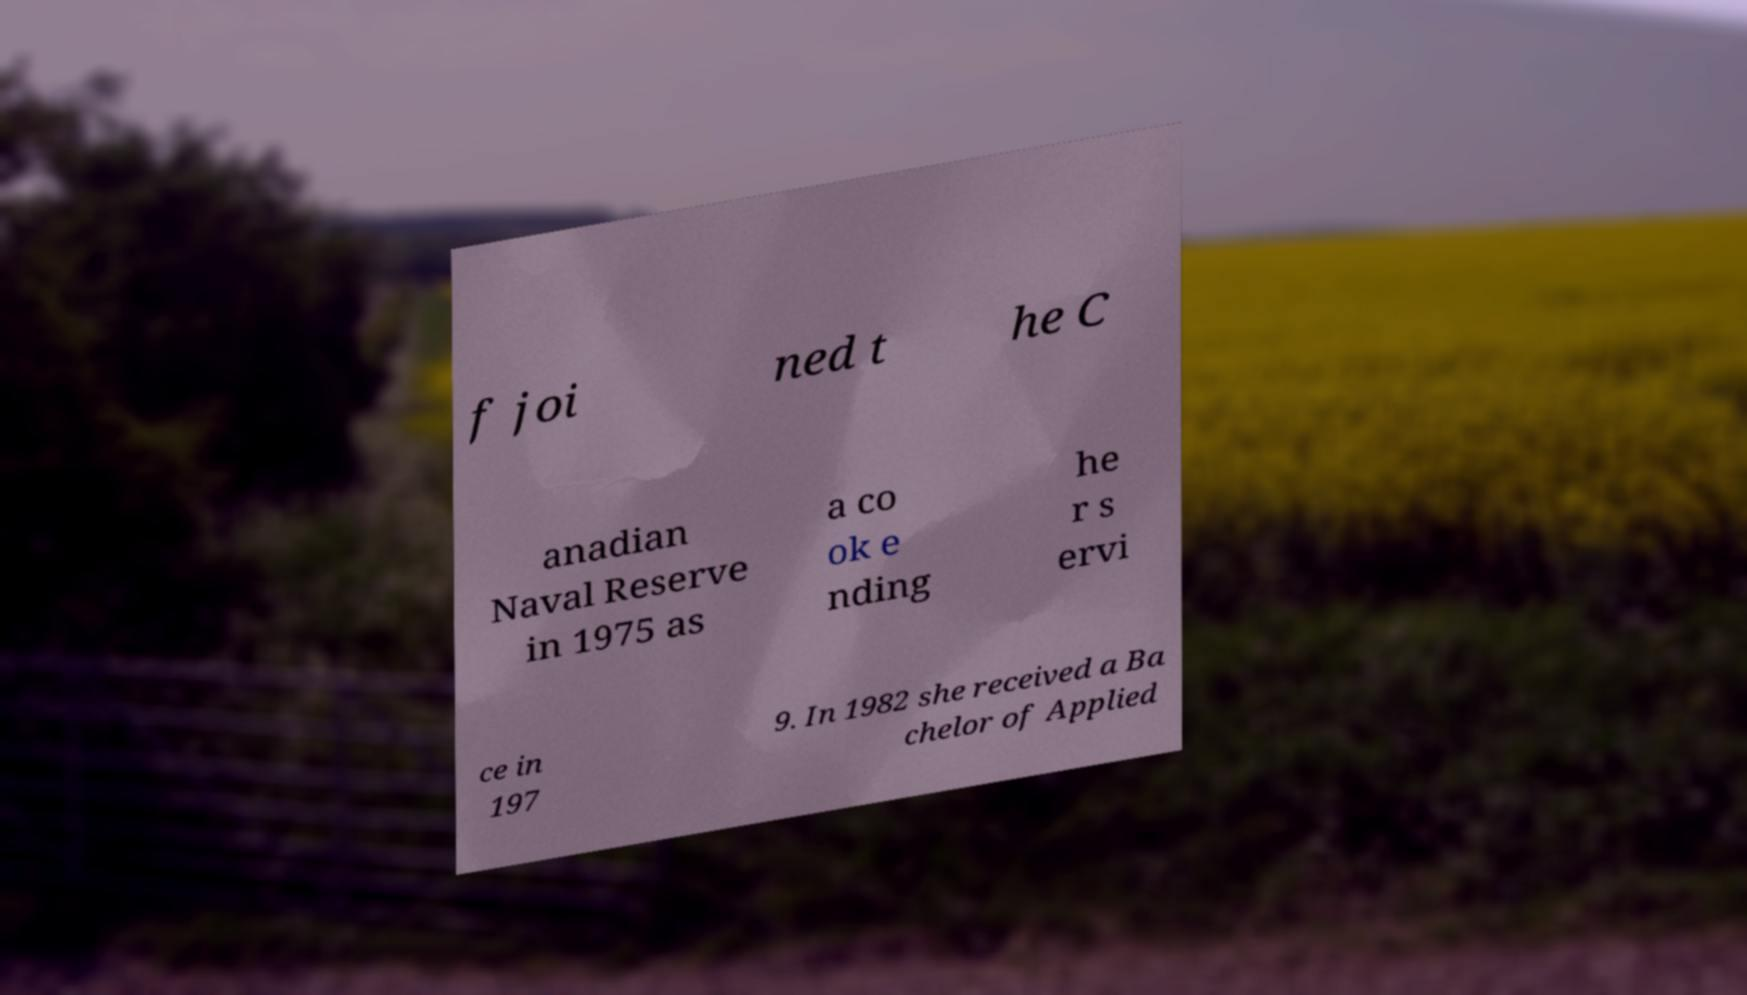Please identify and transcribe the text found in this image. f joi ned t he C anadian Naval Reserve in 1975 as a co ok e nding he r s ervi ce in 197 9. In 1982 she received a Ba chelor of Applied 